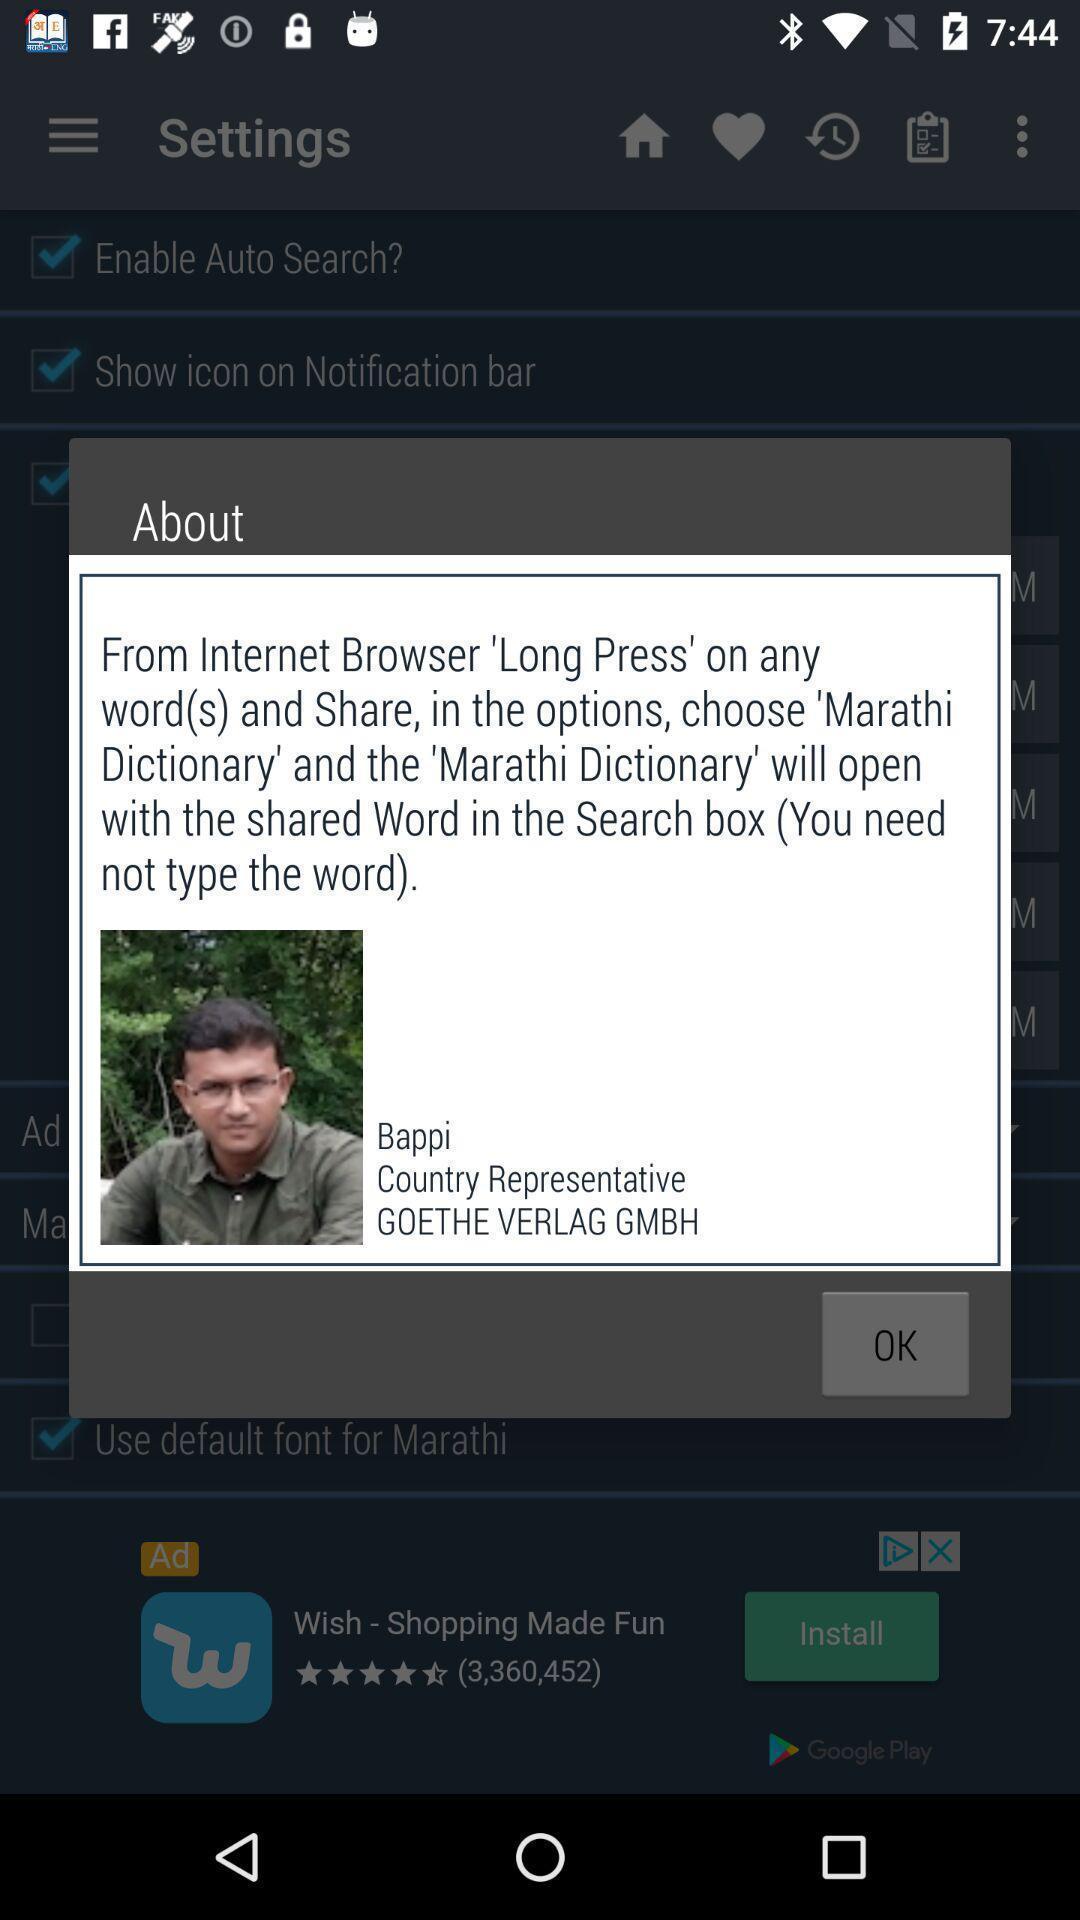Please provide a description for this image. Pop-up displaying information about an application. 